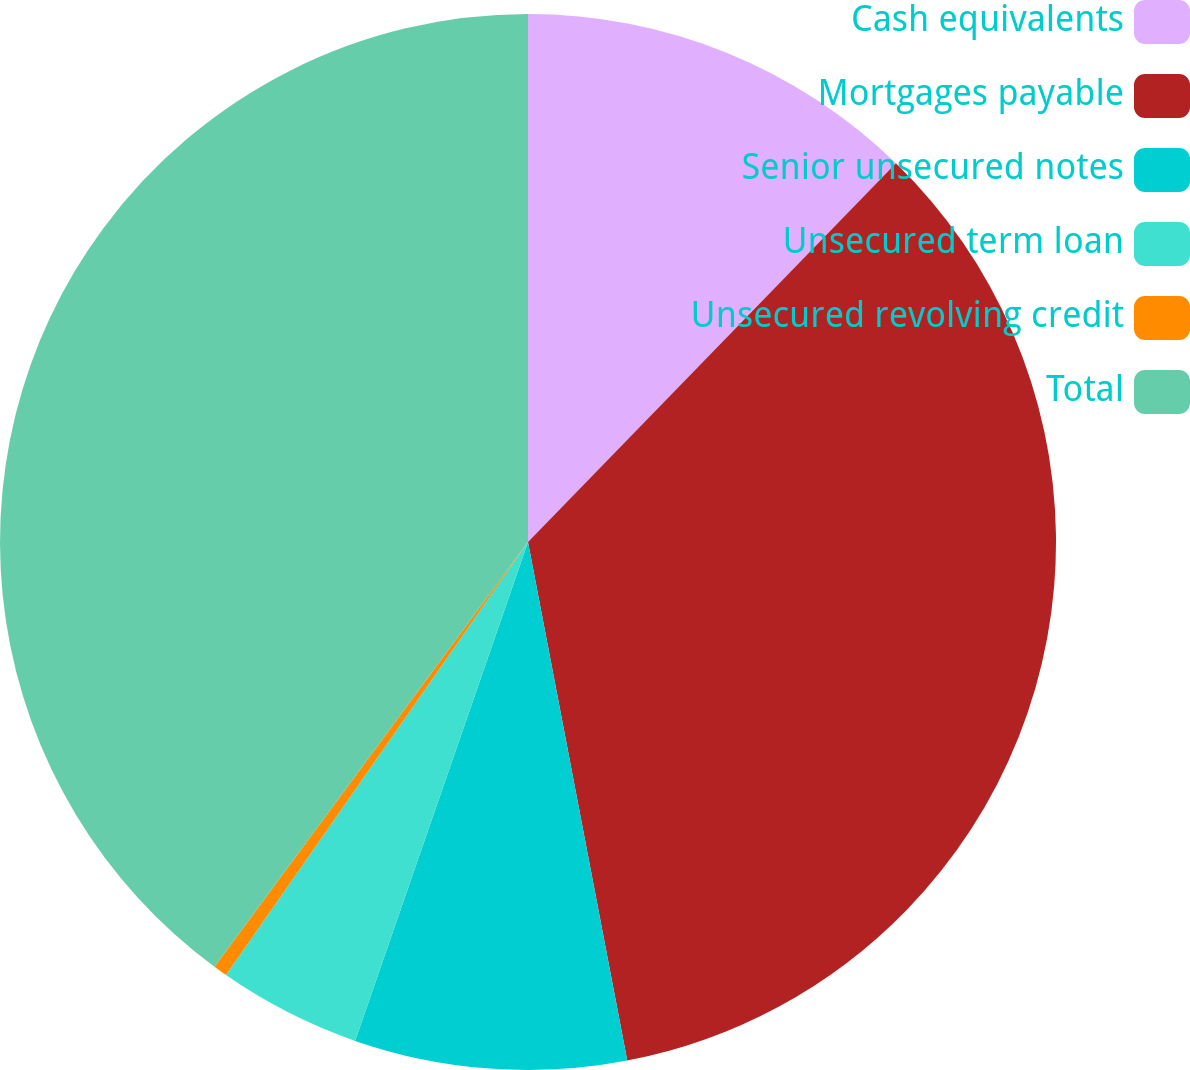<chart> <loc_0><loc_0><loc_500><loc_500><pie_chart><fcel>Cash equivalents<fcel>Mortgages payable<fcel>Senior unsecured notes<fcel>Unsecured term loan<fcel>Unsecured revolving credit<fcel>Total<nl><fcel>12.27%<fcel>34.72%<fcel>8.32%<fcel>4.38%<fcel>0.43%<fcel>39.88%<nl></chart> 